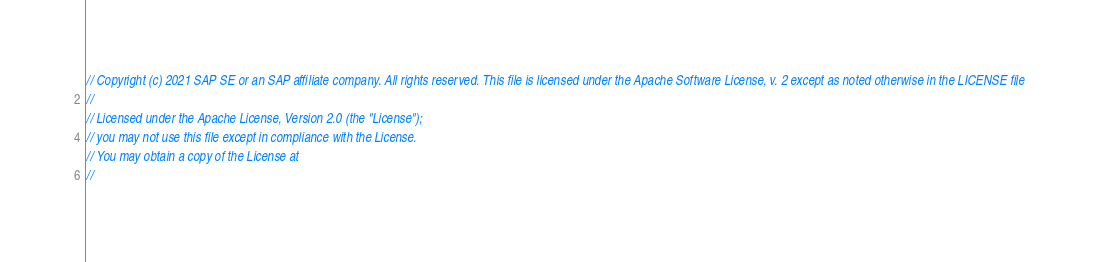Convert code to text. <code><loc_0><loc_0><loc_500><loc_500><_Go_>// Copyright (c) 2021 SAP SE or an SAP affiliate company. All rights reserved. This file is licensed under the Apache Software License, v. 2 except as noted otherwise in the LICENSE file
//
// Licensed under the Apache License, Version 2.0 (the "License");
// you may not use this file except in compliance with the License.
// You may obtain a copy of the License at
//</code> 